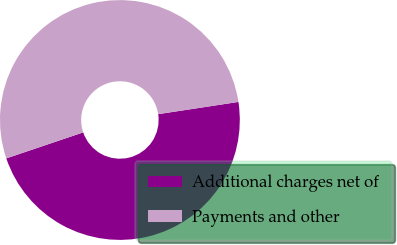Convert chart to OTSL. <chart><loc_0><loc_0><loc_500><loc_500><pie_chart><fcel>Additional charges net of<fcel>Payments and other<nl><fcel>47.22%<fcel>52.78%<nl></chart> 